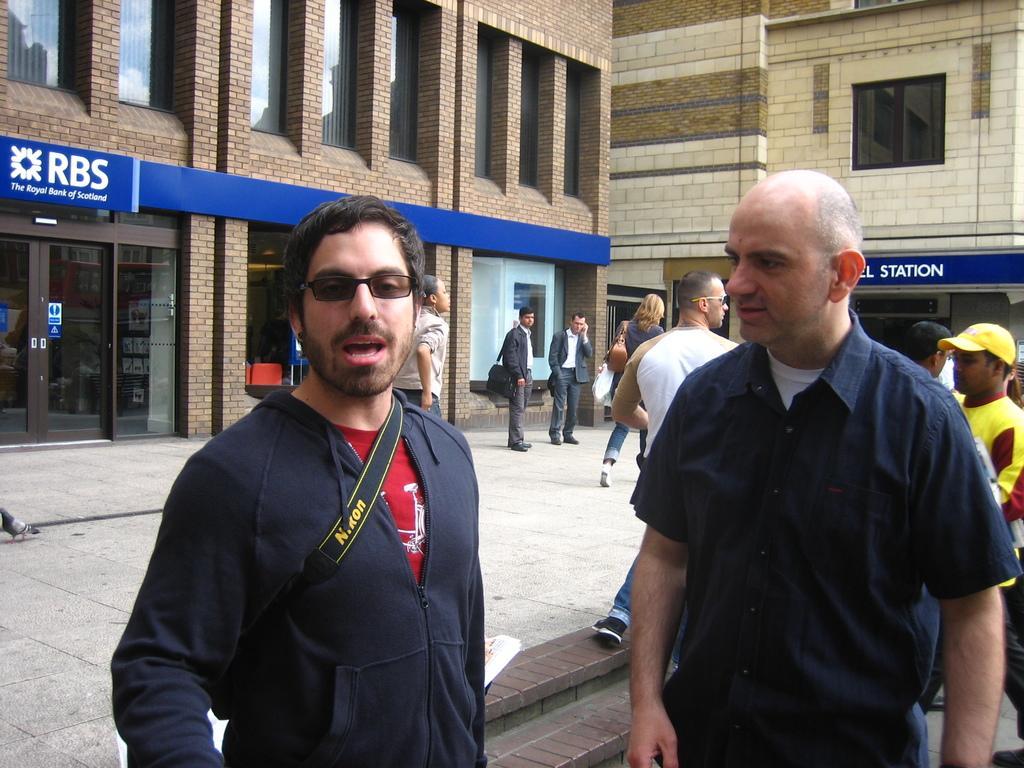How would you summarize this image in a sentence or two? In this image we can see people standing on the road. In the background there are name boards and buildings. 